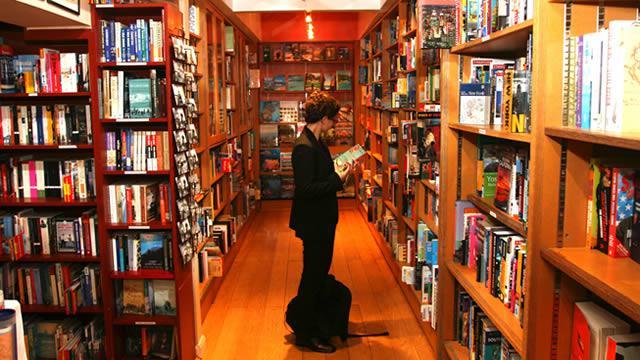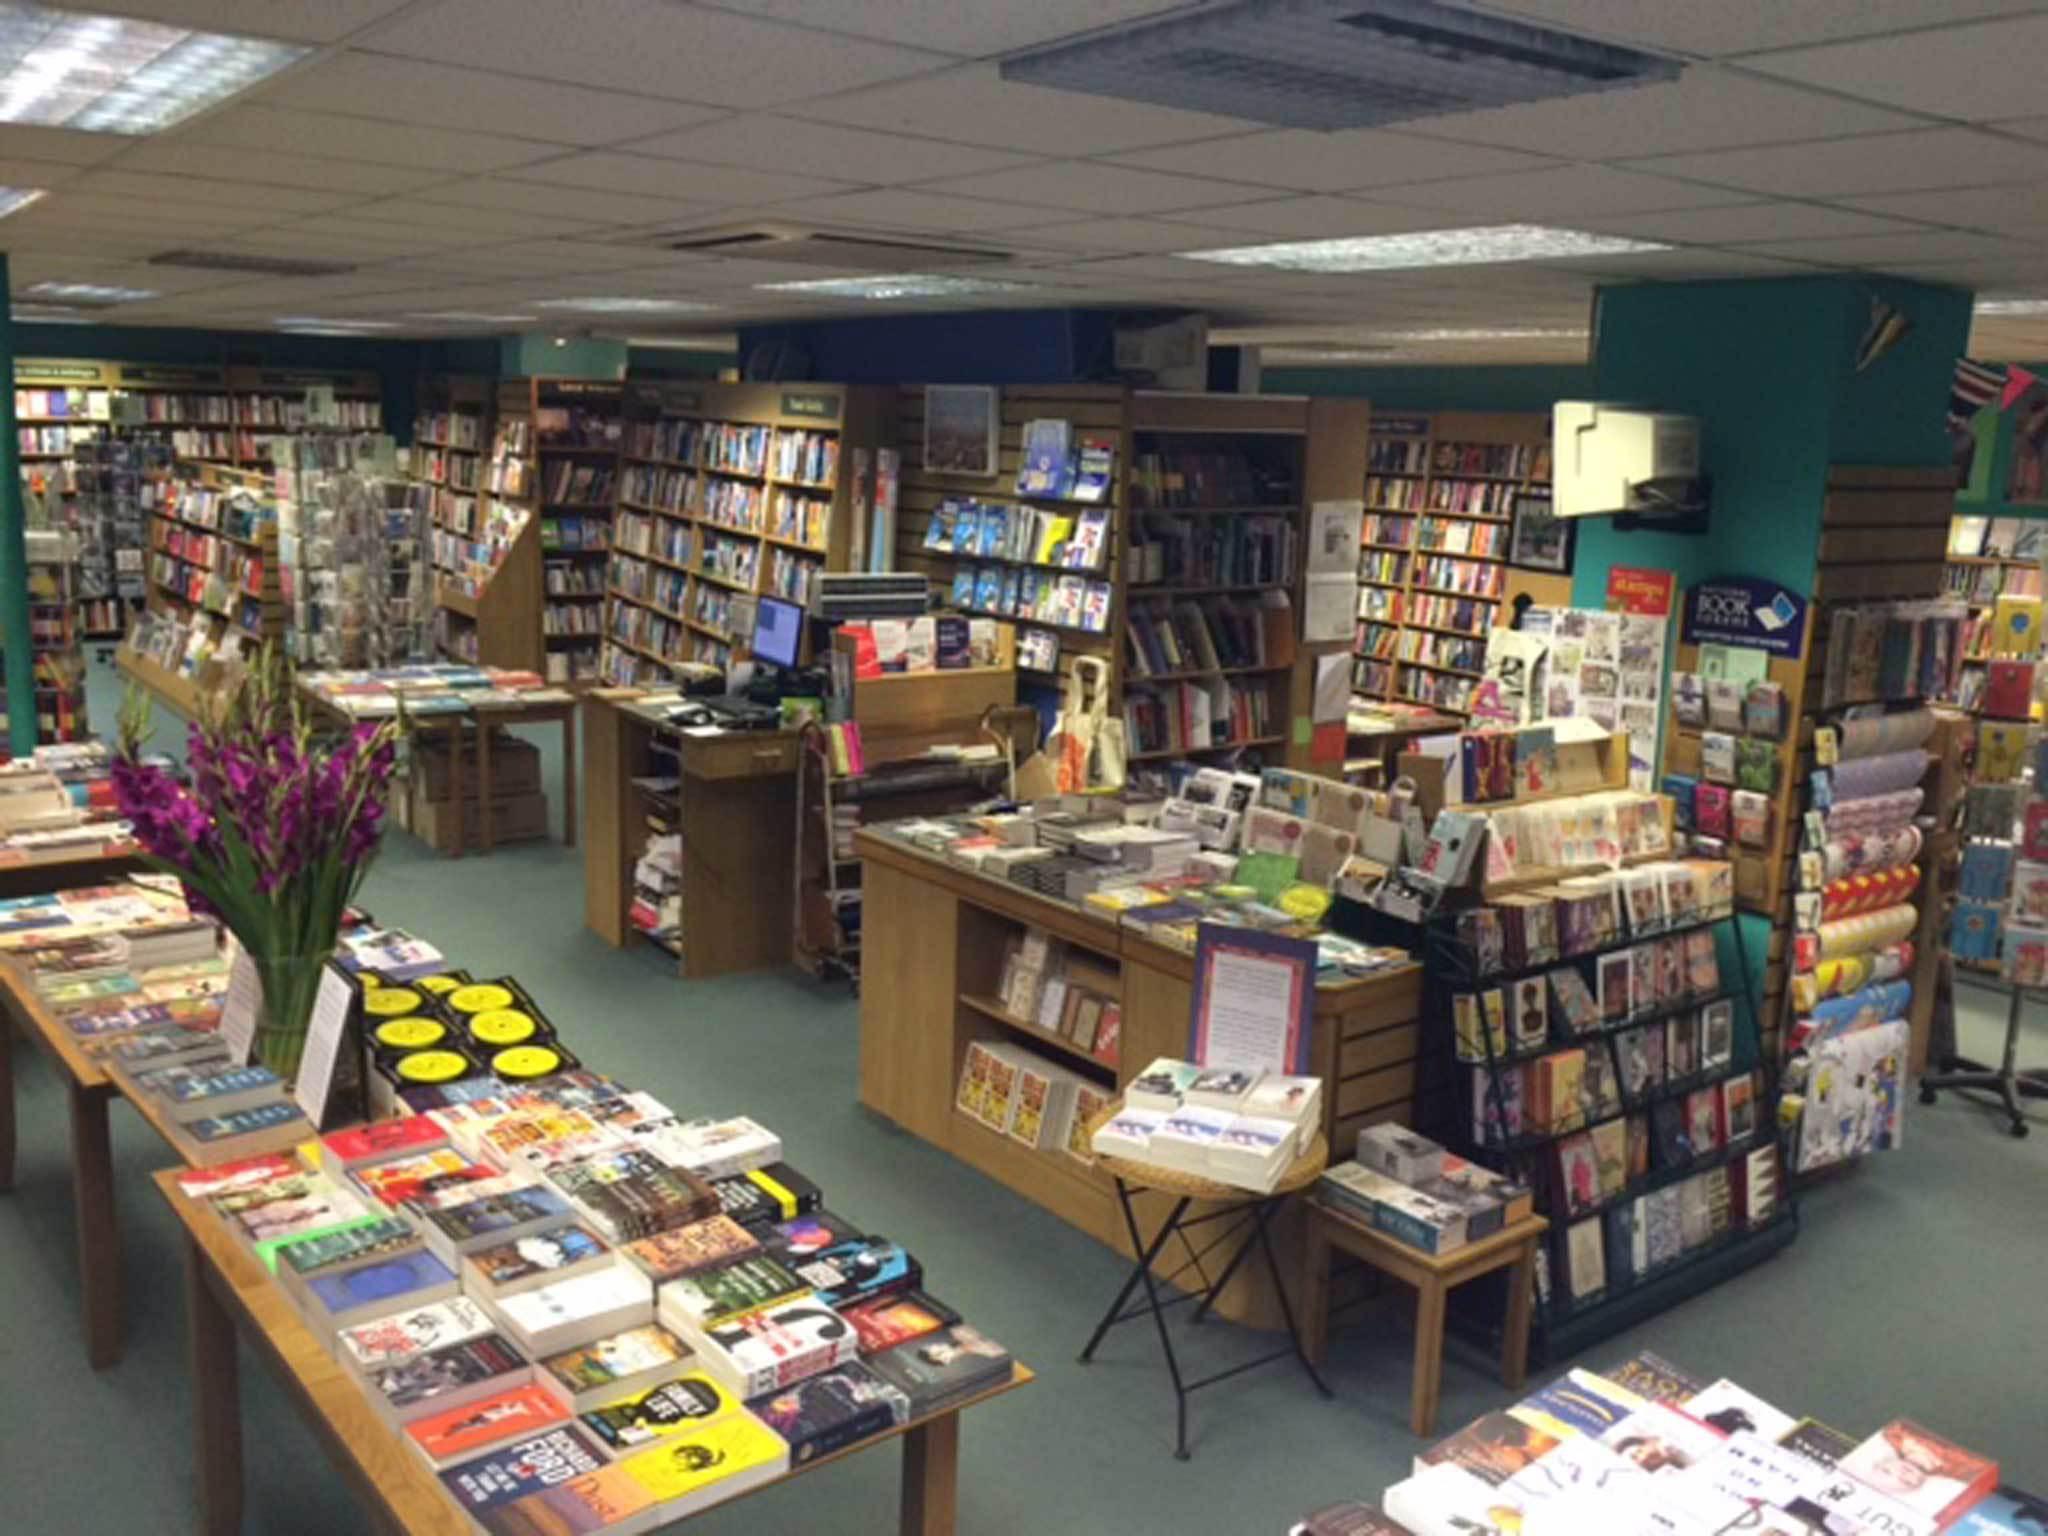The first image is the image on the left, the second image is the image on the right. Given the left and right images, does the statement "There are at least two people in the image on the left." hold true? Answer yes or no. No. 